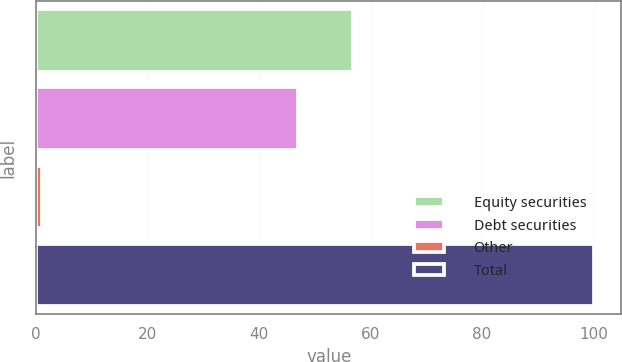Convert chart to OTSL. <chart><loc_0><loc_0><loc_500><loc_500><bar_chart><fcel>Equity securities<fcel>Debt securities<fcel>Other<fcel>Total<nl><fcel>56.9<fcel>47<fcel>1<fcel>100<nl></chart> 